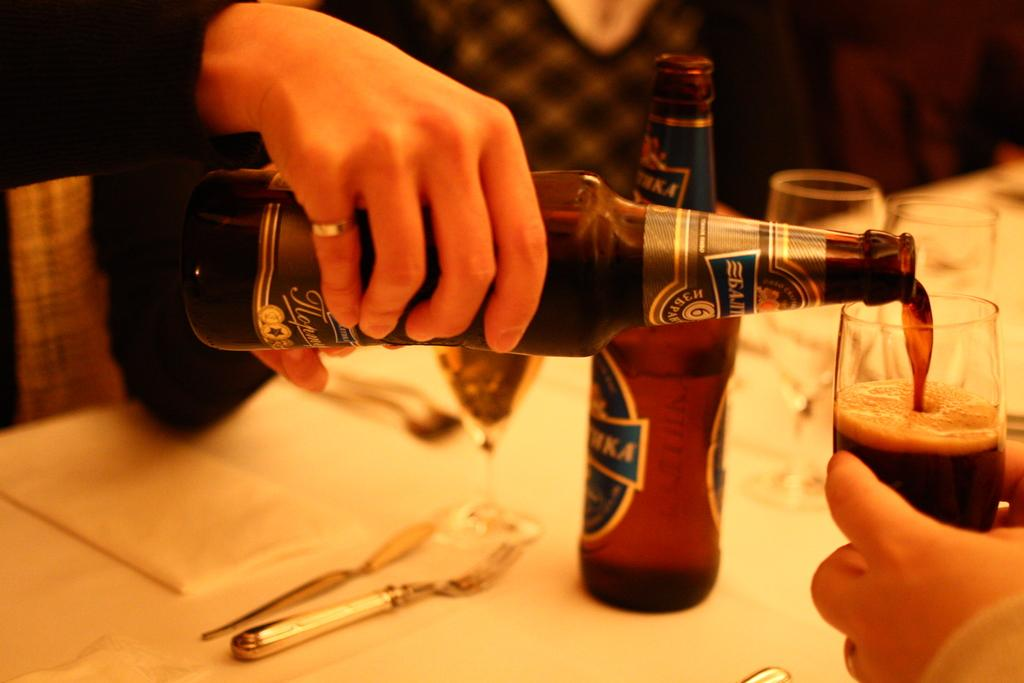What objects are located in the center of the image? There are glass tumblers and beverage bottles in the center of the image. Can you describe the person in the background of the image? The person in the background of the image is holding a beverage bottle. Reasoning: Let's think step by identifying the main subjects and objects in the image based on the provided facts. We then formulate questions that focus on the location and characteristics of these subjects and objects, ensuring that each question can be answered definitively with the information given. We avoid yes/no questions and ensure that the language is simple and clear. Absurd Question/Answer: What type of locket is the person wearing in the image? There is no locket visible in the image. Where can you find the nearest shop to purchase beverage bottles in the image? The image does not provide information about the location of a shop. What type of spoon is the person using to stir the beverage in the image? There is no spoon visible in the image, and the person is not stirring a beverage. 